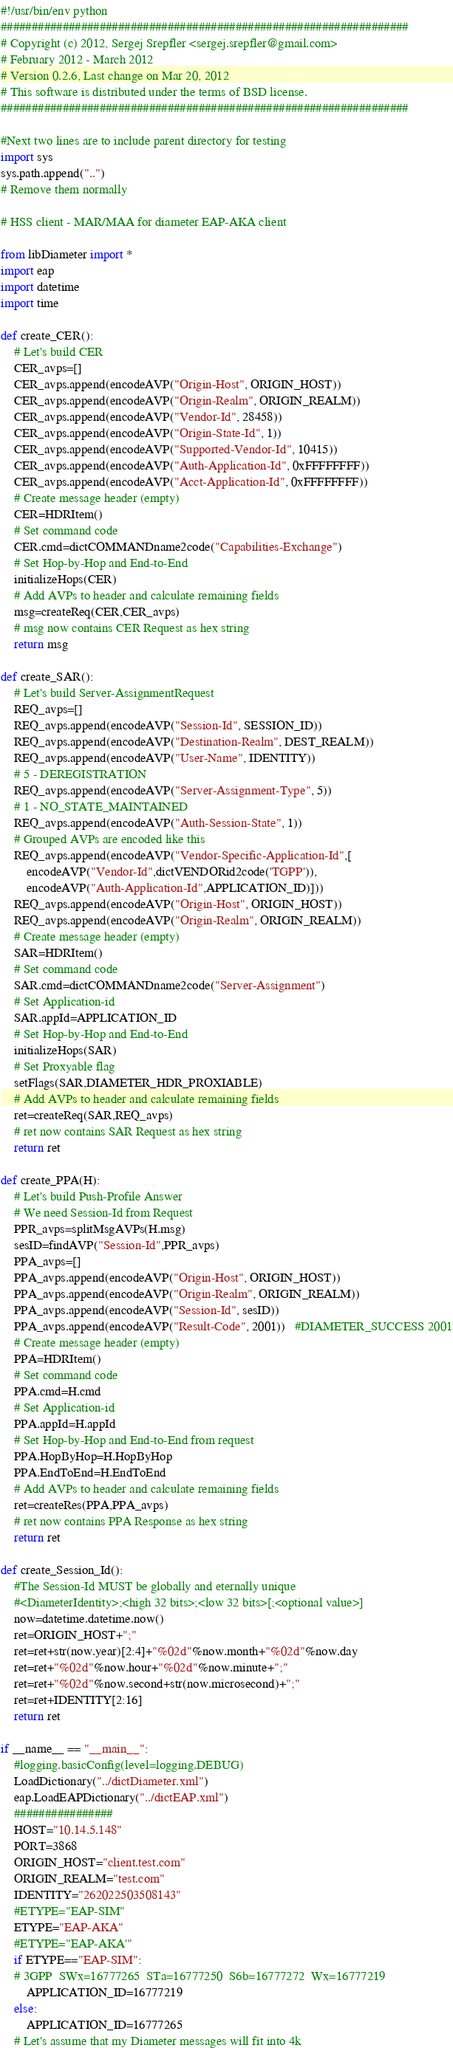Convert code to text. <code><loc_0><loc_0><loc_500><loc_500><_Python_>#!/usr/bin/env python
##################################################################
# Copyright (c) 2012, Sergej Srepfler <sergej.srepfler@gmail.com>
# February 2012 - March 2012
# Version 0.2.6, Last change on Mar 20, 2012
# This software is distributed under the terms of BSD license.    
##################################################################

#Next two lines are to include parent directory for testing
import sys
sys.path.append("..")
# Remove them normally

# HSS client - MAR/MAA for diameter EAP-AKA client

from libDiameter import *
import eap
import datetime
import time

def create_CER():
    # Let's build CER
    CER_avps=[]
    CER_avps.append(encodeAVP("Origin-Host", ORIGIN_HOST))
    CER_avps.append(encodeAVP("Origin-Realm", ORIGIN_REALM))
    CER_avps.append(encodeAVP("Vendor-Id", 28458))
    CER_avps.append(encodeAVP("Origin-State-Id", 1))
    CER_avps.append(encodeAVP("Supported-Vendor-Id", 10415))
    CER_avps.append(encodeAVP("Auth-Application-Id", 0xFFFFFFFF))
    CER_avps.append(encodeAVP("Acct-Application-Id", 0xFFFFFFFF))
    # Create message header (empty)
    CER=HDRItem()
    # Set command code
    CER.cmd=dictCOMMANDname2code("Capabilities-Exchange")
    # Set Hop-by-Hop and End-to-End
    initializeHops(CER)
    # Add AVPs to header and calculate remaining fields
    msg=createReq(CER,CER_avps)
    # msg now contains CER Request as hex string
    return msg
       
def create_SAR():
    # Let's build Server-AssignmentRequest
    REQ_avps=[]
    REQ_avps.append(encodeAVP("Session-Id", SESSION_ID))
    REQ_avps.append(encodeAVP("Destination-Realm", DEST_REALM))
    REQ_avps.append(encodeAVP("User-Name", IDENTITY)) 
    # 5 - DEREGISTRATION
    REQ_avps.append(encodeAVP("Server-Assignment-Type", 5)) 
    # 1 - NO_STATE_MAINTAINED
    REQ_avps.append(encodeAVP("Auth-Session-State", 1))     
    # Grouped AVPs are encoded like this
    REQ_avps.append(encodeAVP("Vendor-Specific-Application-Id",[
        encodeAVP("Vendor-Id",dictVENDORid2code('TGPP')),
        encodeAVP("Auth-Application-Id",APPLICATION_ID)]))
    REQ_avps.append(encodeAVP("Origin-Host", ORIGIN_HOST))
    REQ_avps.append(encodeAVP("Origin-Realm", ORIGIN_REALM))
    # Create message header (empty)
    SAR=HDRItem()
    # Set command code
    SAR.cmd=dictCOMMANDname2code("Server-Assignment")
    # Set Application-id
    SAR.appId=APPLICATION_ID
    # Set Hop-by-Hop and End-to-End
    initializeHops(SAR)
    # Set Proxyable flag
    setFlags(SAR,DIAMETER_HDR_PROXIABLE)    
    # Add AVPs to header and calculate remaining fields
    ret=createReq(SAR,REQ_avps)
    # ret now contains SAR Request as hex string
    return ret 
    
def create_PPA(H):
    # Let's build Push-Profile Answer
    # We need Session-Id from Request
    PPR_avps=splitMsgAVPs(H.msg)
    sesID=findAVP("Session-Id",PPR_avps) 
    PPA_avps=[]
    PPA_avps.append(encodeAVP("Origin-Host", ORIGIN_HOST))
    PPA_avps.append(encodeAVP("Origin-Realm", ORIGIN_REALM))
    PPA_avps.append(encodeAVP("Session-Id", sesID))
    PPA_avps.append(encodeAVP("Result-Code", 2001))   #DIAMETER_SUCCESS 2001
    # Create message header (empty)
    PPA=HDRItem()
    # Set command code
    PPA.cmd=H.cmd
    # Set Application-id
    PPA.appId=H.appId
    # Set Hop-by-Hop and End-to-End from request
    PPA.HopByHop=H.HopByHop
    PPA.EndToEnd=H.EndToEnd
    # Add AVPs to header and calculate remaining fields
    ret=createRes(PPA,PPA_avps)
    # ret now contains PPA Response as hex string
    return ret     
    
def create_Session_Id():
    #The Session-Id MUST be globally and eternally unique
    #<DiameterIdentity>;<high 32 bits>;<low 32 bits>[;<optional value>]
    now=datetime.datetime.now()
    ret=ORIGIN_HOST+";"
    ret=ret+str(now.year)[2:4]+"%02d"%now.month+"%02d"%now.day
    ret=ret+"%02d"%now.hour+"%02d"%now.minute+";"
    ret=ret+"%02d"%now.second+str(now.microsecond)+";"
    ret=ret+IDENTITY[2:16]
    return ret
 
if __name__ == "__main__":
    #logging.basicConfig(level=logging.DEBUG)
    LoadDictionary("../dictDiameter.xml")
    eap.LoadEAPDictionary("../dictEAP.xml")
    ################
    HOST="10.14.5.148"
    PORT=3868
    ORIGIN_HOST="client.test.com"
    ORIGIN_REALM="test.com"
    IDENTITY="262022503508143"                        
    #ETYPE="EAP-SIM"
    ETYPE="EAP-AKA"
    #ETYPE="EAP-AKA'"
    if ETYPE=="EAP-SIM":
    # 3GPP  SWx=16777265  STa=16777250  S6b=16777272  Wx=16777219
        APPLICATION_ID=16777219
    else:
        APPLICATION_ID=16777265                
    # Let's assume that my Diameter messages will fit into 4k</code> 